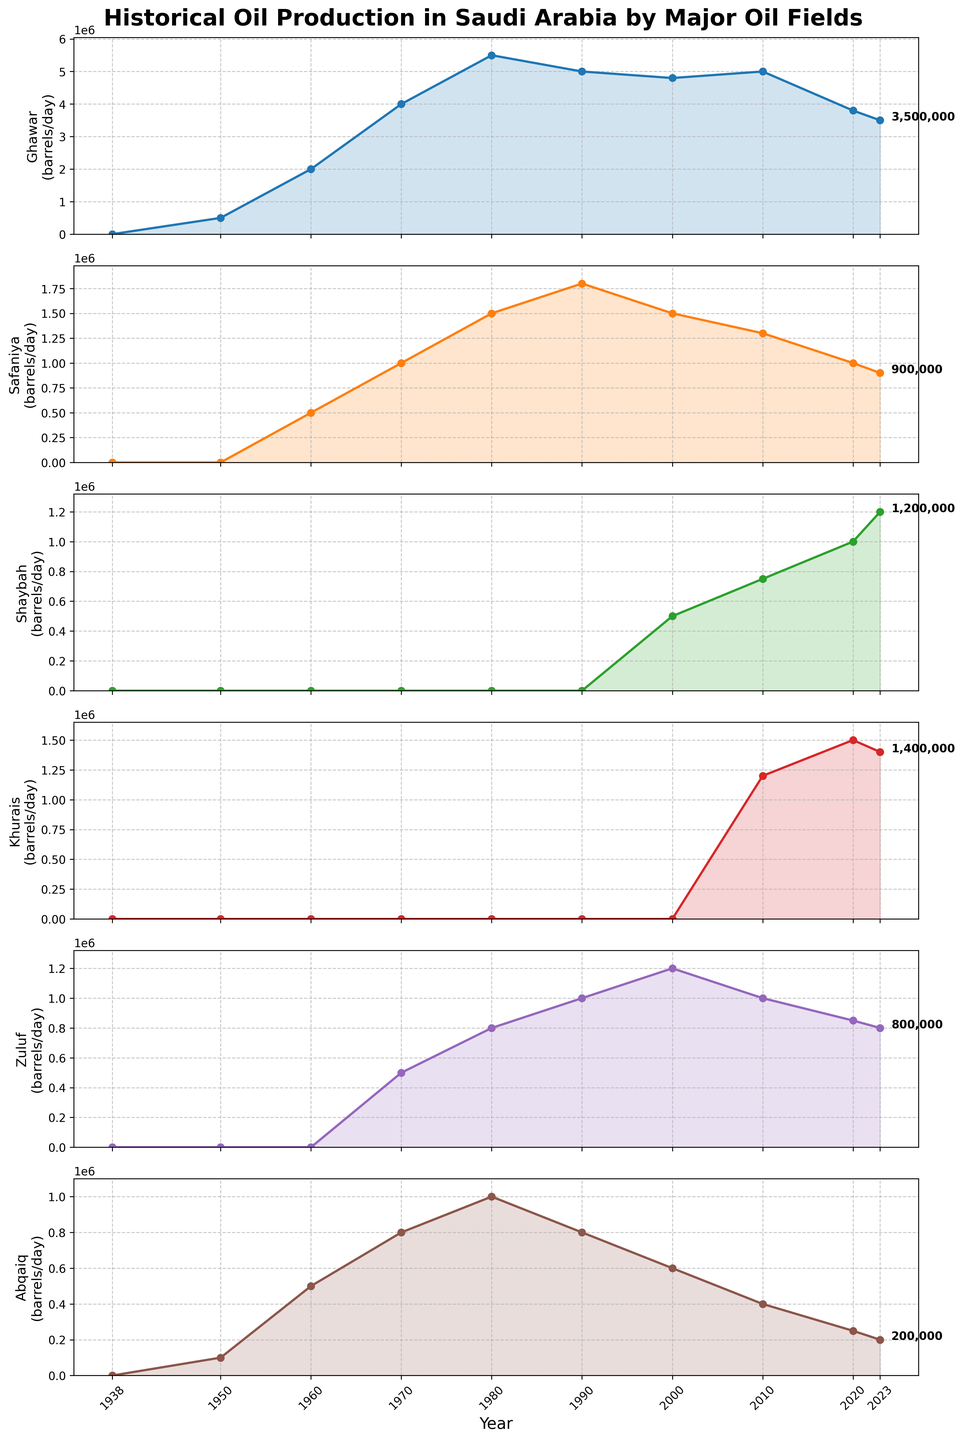What is the maximum production value of the Ghawar oil field and in which year did it occur? The Ghawar oil field plot line reaches its highest point at 5,500,000 barrels/day in 1980.
Answer: 5,500,000 barrels/day in 1980 How did the production of the Safaniya oil field change between 1950 and 1980? The production of the Safaniya oil field started at 0 in 1950 and rose to 1,500,000 barrels/day by 1980. The change is calculated as 1,500,000 - 0.
Answer: Increased by 1,500,000 barrels/day Which oil field showed the most consistent production from 2000 to 2023? Looking at the subplots, the Ghawar oil field maintained production around 4,800,000 to 5,000,000 barrels/day with slight decreases toward 2020 and 2023.
Answer: Ghawar What is the difference in production between the Shaybah and Khurais oil fields in 2020? In 2020, the Shaybah oil field produced 1,000,000 barrels/day, while the Khurais oil field produced 1,500,000 barrels/day. The difference is 1,500,000 - 1,000,000.
Answer: 500,000 barrels/day Which oil field had the lowest production in 2023? In 2023, comparing the values on the plot lines for all fields, Abqaiq had the lowest production at 200,000 barrels/day.
Answer: Abqaiq What is the average production of the Zuluf oil field from 1980 to 2023? To find the average, add the production values of Zuluf for the years mentioned: (800,000 + 1,000,000 + 1,200,000 + 1,000,000 + 850,000 + 800,000)/6 = 5,650,000 / 6.
Answer: Approximately 941,667 barrels/day Which two oil fields had overlapping production values in 2023, and what were the values? The Shaybah and Khurais oil fields both had production values around 1,200,000 and 1,400,000 barrels/day respectively in 2023.
Answer: Shaybah (1,200,000) and Khurais (1,400,000) What trend can be observed in the production levels of Abqaiq from 1938 to 2023? The production of Abqaiq initially increased from 100,000 to 1,000,000 barrels/day by 1980, then decreased gradually reaching 200,000 barrels/day in 2023.
Answer: Initial increase and gradual decrease Between which years did the Ghawar oil field see the fastest production increase? The Ghawar oil field saw the fastest increase between 1950 and 1960, going from 500,000 to 2,000,000 barrels/day.
Answer: 1950 to 1960 In which decade did the Safaniya and Zuluf oil fields both start producing oil? Both the Safaniya and Zuluf oil fields started production in the 1960s and 1970s respectively according to the plot information.
Answer: 1960s for Safaniya, 1970s for Zuluf 